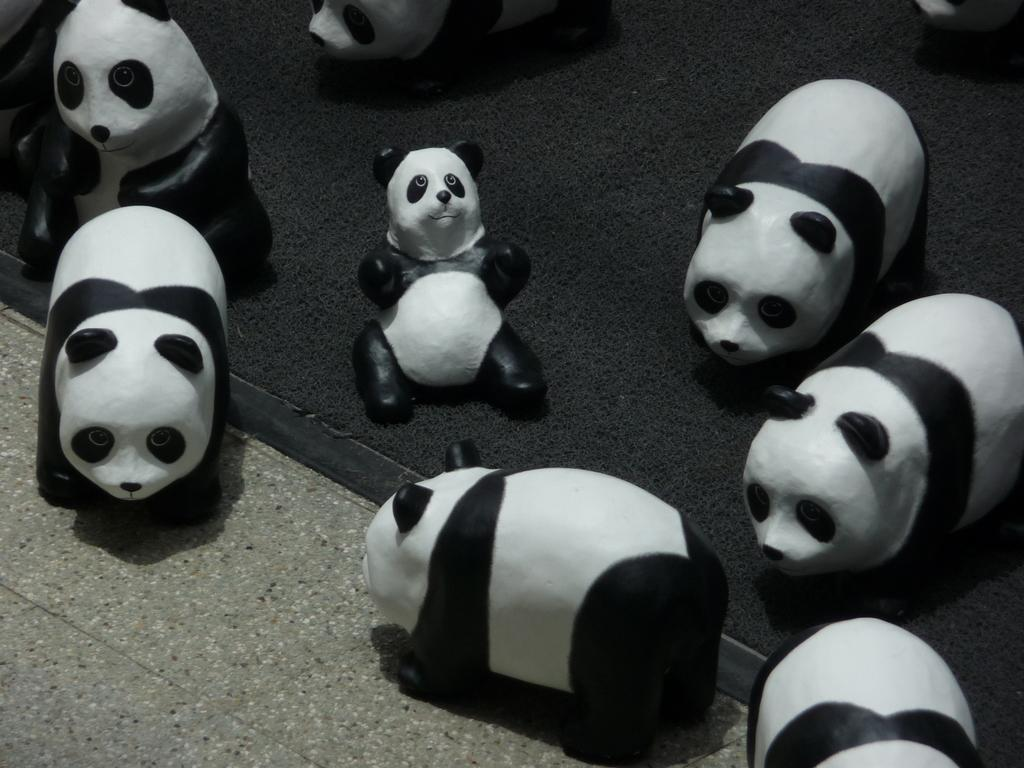What type of toys are present in the image? There are panda toys in the image. What is the color of the surface on which the toys are placed? The toys are on a black surface. What type of bells can be heard ringing in the image? There are no bells present in the image, and therefore no sound can be heard. 